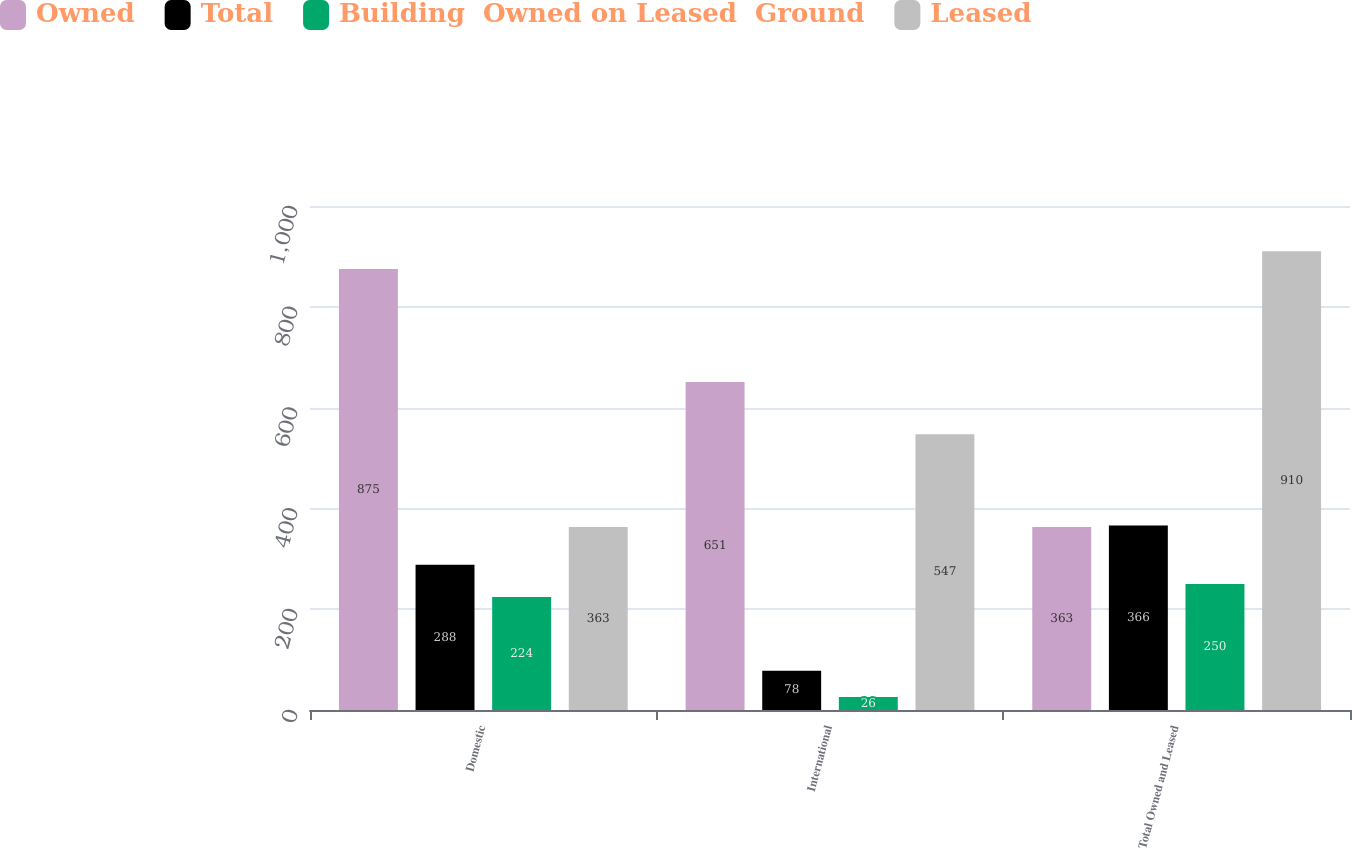Convert chart to OTSL. <chart><loc_0><loc_0><loc_500><loc_500><stacked_bar_chart><ecel><fcel>Domestic<fcel>International<fcel>Total Owned and Leased<nl><fcel>Owned<fcel>875<fcel>651<fcel>363<nl><fcel>Total<fcel>288<fcel>78<fcel>366<nl><fcel>Building  Owned on Leased  Ground<fcel>224<fcel>26<fcel>250<nl><fcel>Leased<fcel>363<fcel>547<fcel>910<nl></chart> 